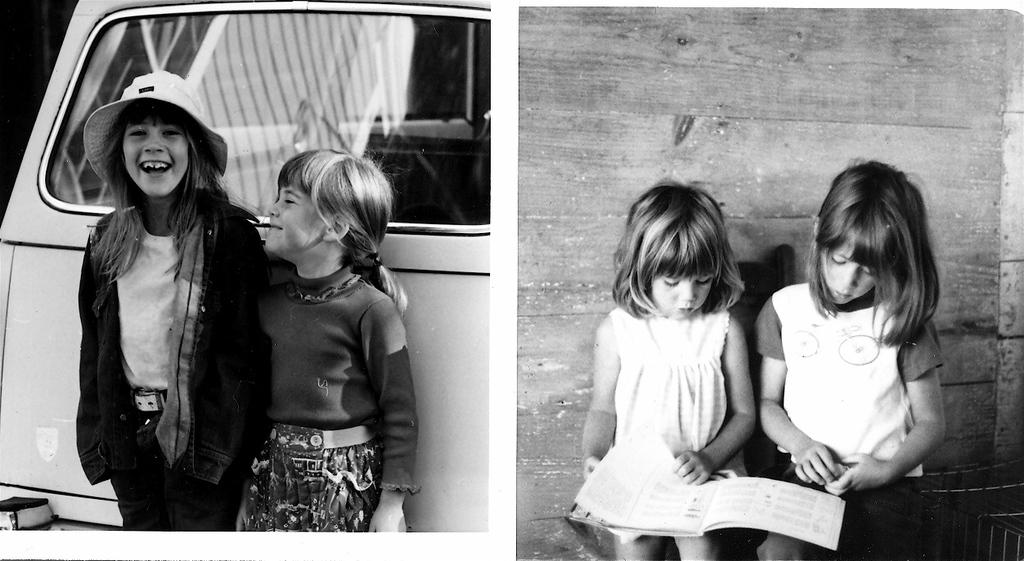How many girls are present in the image? There are four girls in the image. What are the girls on the right side of the image doing? The two girls on the right side are looking into a book. What is the facial expression of the girls on the left side of the image? The two girls on the left side are smiling. Where is the baby playing in the field in the image? There is no baby or field present in the image. What type of car can be seen in the background of the image? There is no car visible in the image. 